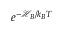Convert formula to latex. <formula><loc_0><loc_0><loc_500><loc_500>e ^ { - \mathcal { H } _ { B } / k _ { B } T }</formula> 